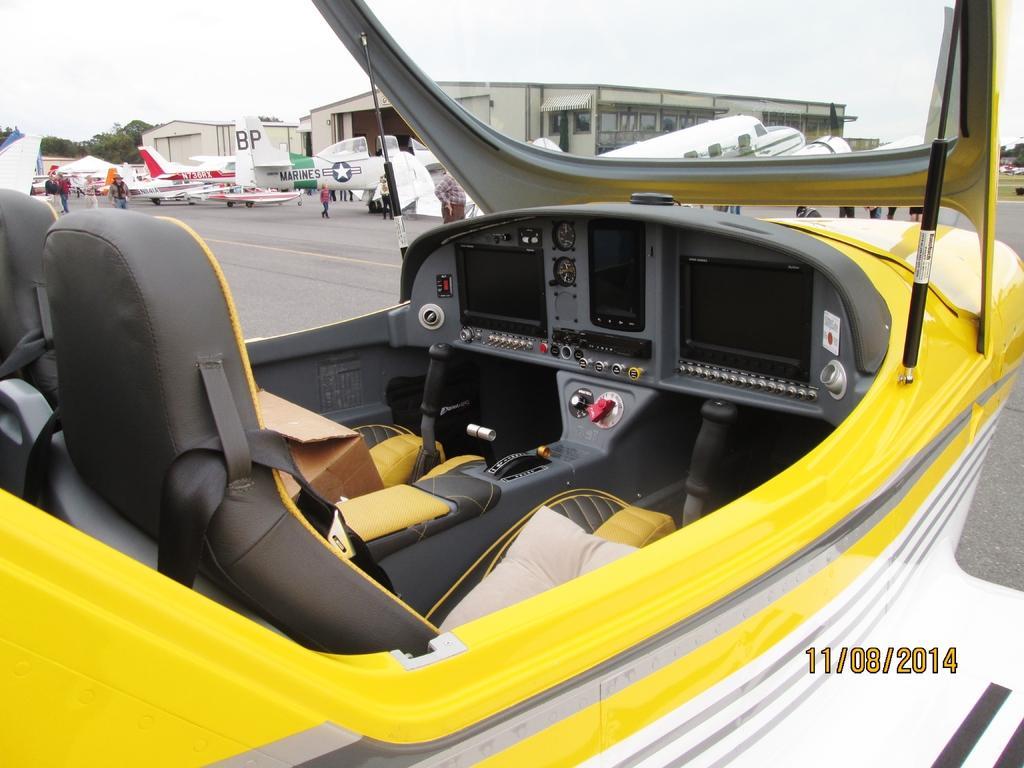Could you give a brief overview of what you see in this image? In this image, I can see the airplanes on the runway and few people standing. In the background, there are buildings, trees and the sky. At the bottom right side of the image, I can see the watermark. 